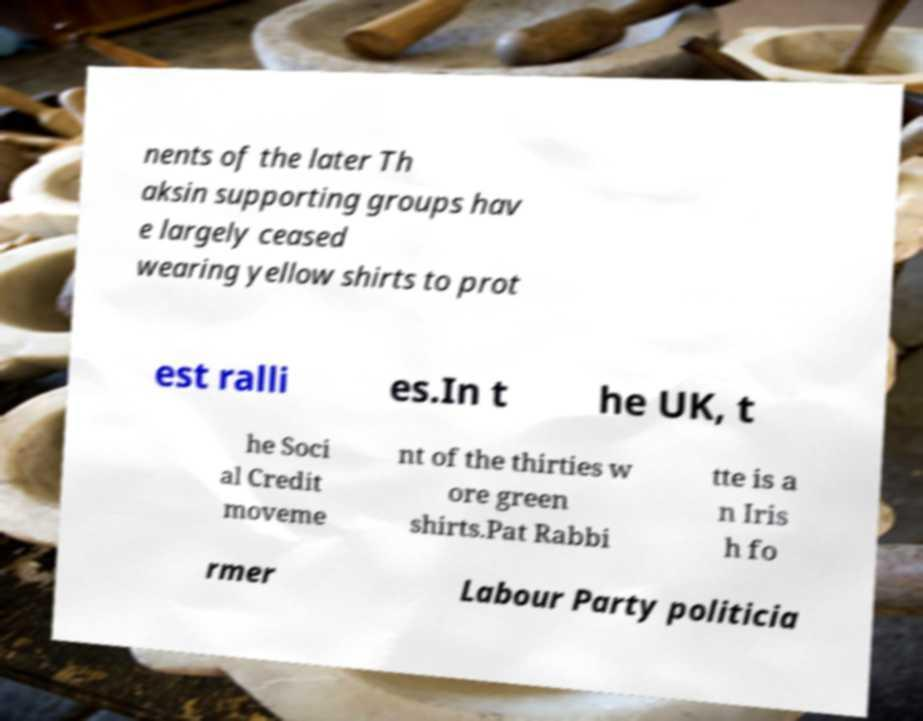There's text embedded in this image that I need extracted. Can you transcribe it verbatim? nents of the later Th aksin supporting groups hav e largely ceased wearing yellow shirts to prot est ralli es.In t he UK, t he Soci al Credit moveme nt of the thirties w ore green shirts.Pat Rabbi tte is a n Iris h fo rmer Labour Party politicia 